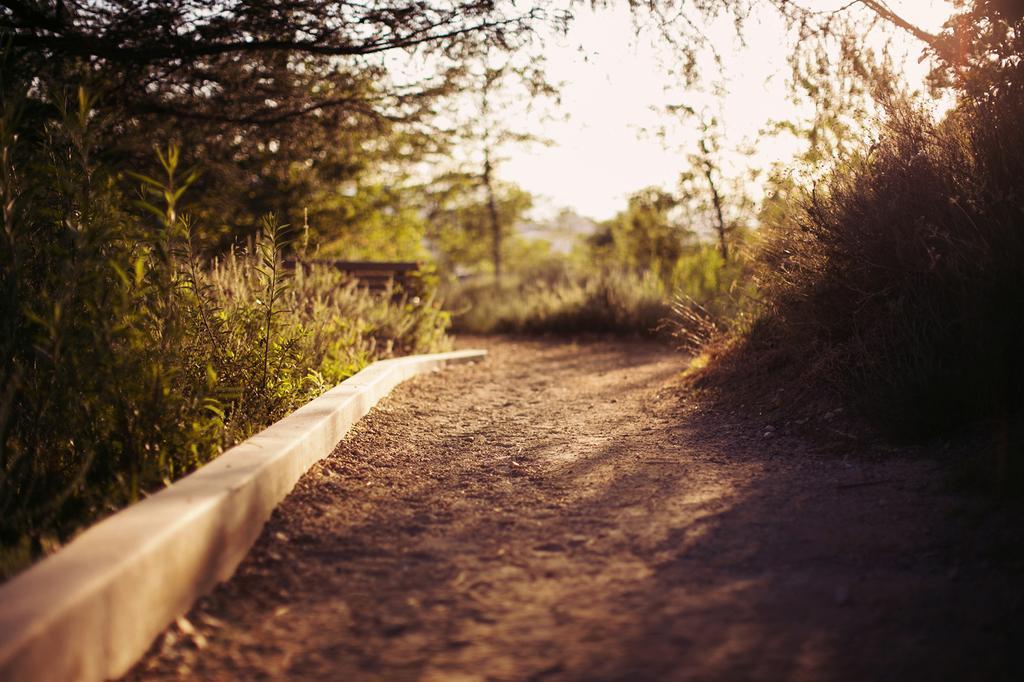Could you give a brief overview of what you see in this image? In this image we can see walkway. On the left side of the image there are trees and plants. On the right side we can see trees and plants. In the background there is a sky. 